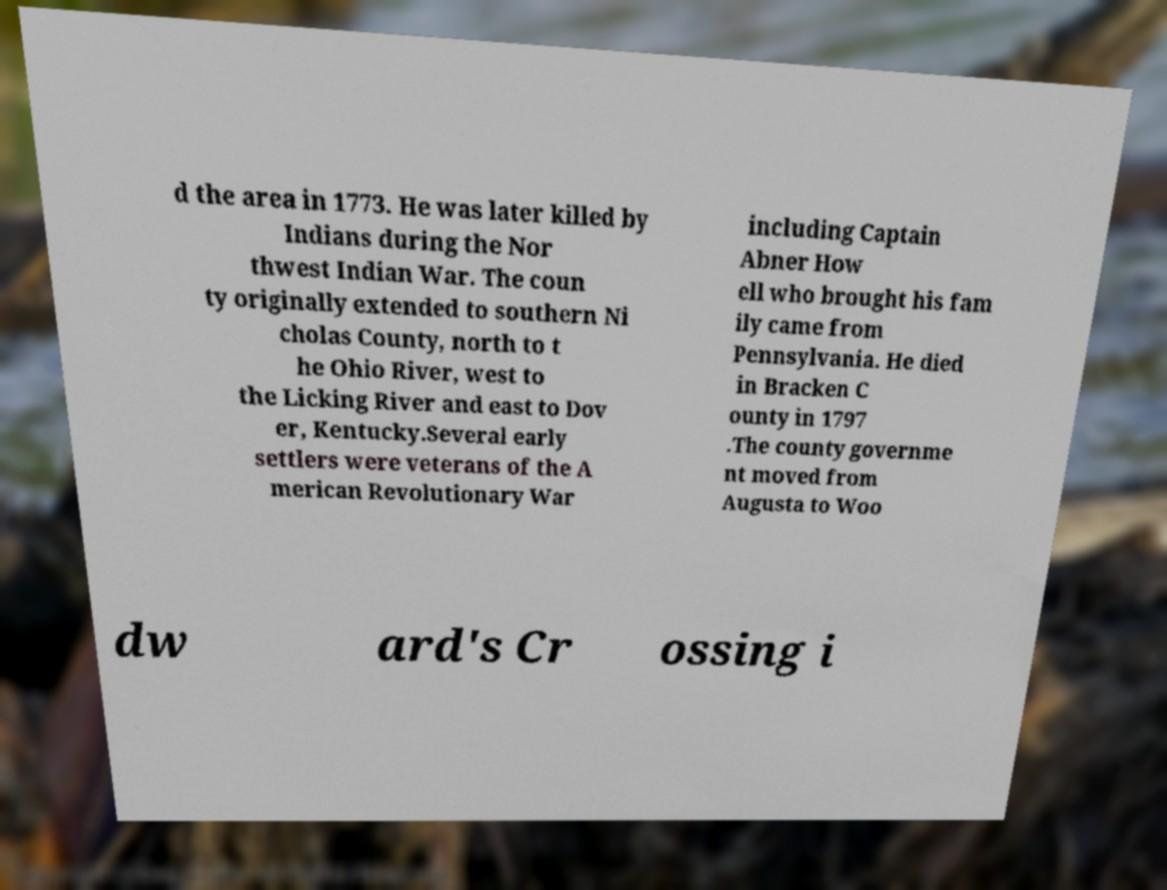There's text embedded in this image that I need extracted. Can you transcribe it verbatim? d the area in 1773. He was later killed by Indians during the Nor thwest Indian War. The coun ty originally extended to southern Ni cholas County, north to t he Ohio River, west to the Licking River and east to Dov er, Kentucky.Several early settlers were veterans of the A merican Revolutionary War including Captain Abner How ell who brought his fam ily came from Pennsylvania. He died in Bracken C ounty in 1797 .The county governme nt moved from Augusta to Woo dw ard's Cr ossing i 